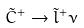<formula> <loc_0><loc_0><loc_500><loc_500>\tilde { C } ^ { + } \rightarrow \tilde { l } ^ { + } \nu</formula> 